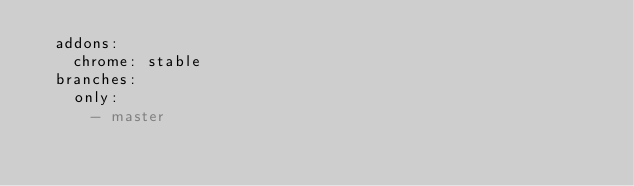Convert code to text. <code><loc_0><loc_0><loc_500><loc_500><_YAML_>  addons:
    chrome: stable
  branches:
    only:
      - master</code> 